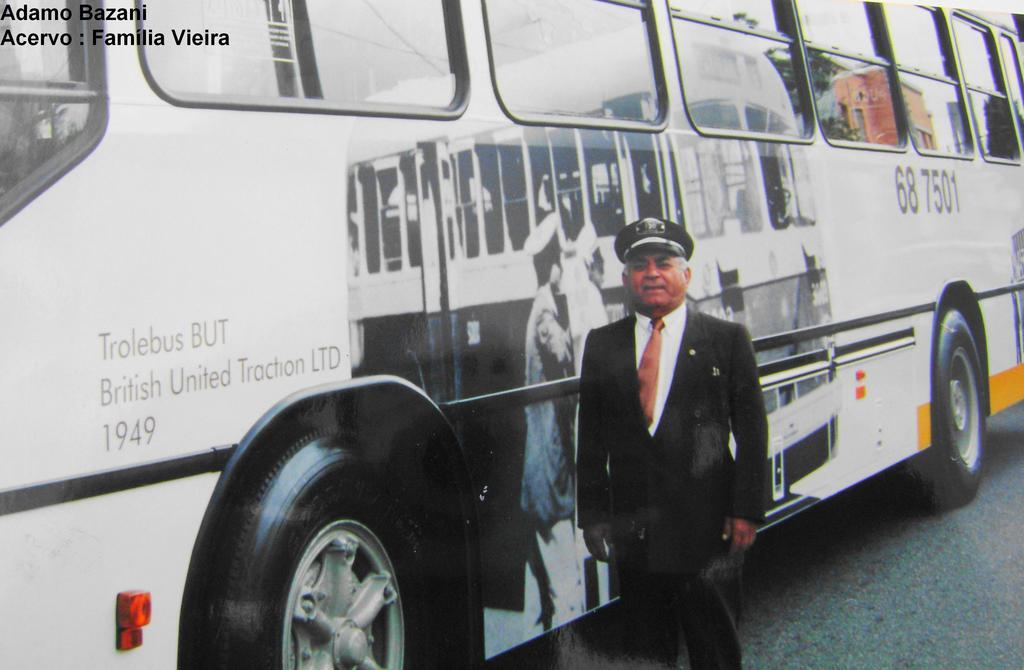<image>
Provide a brief description of the given image. The bus identification number is cited as 68 7501. 